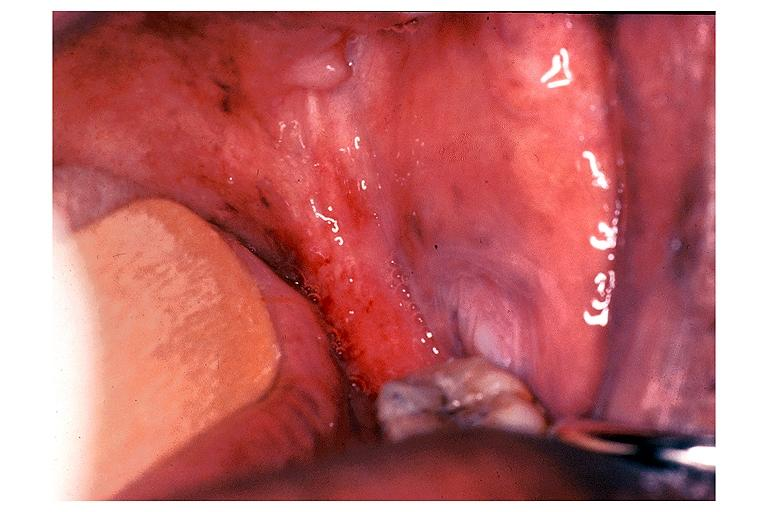s chronic myelogenous leukemia present?
Answer the question using a single word or phrase. No 